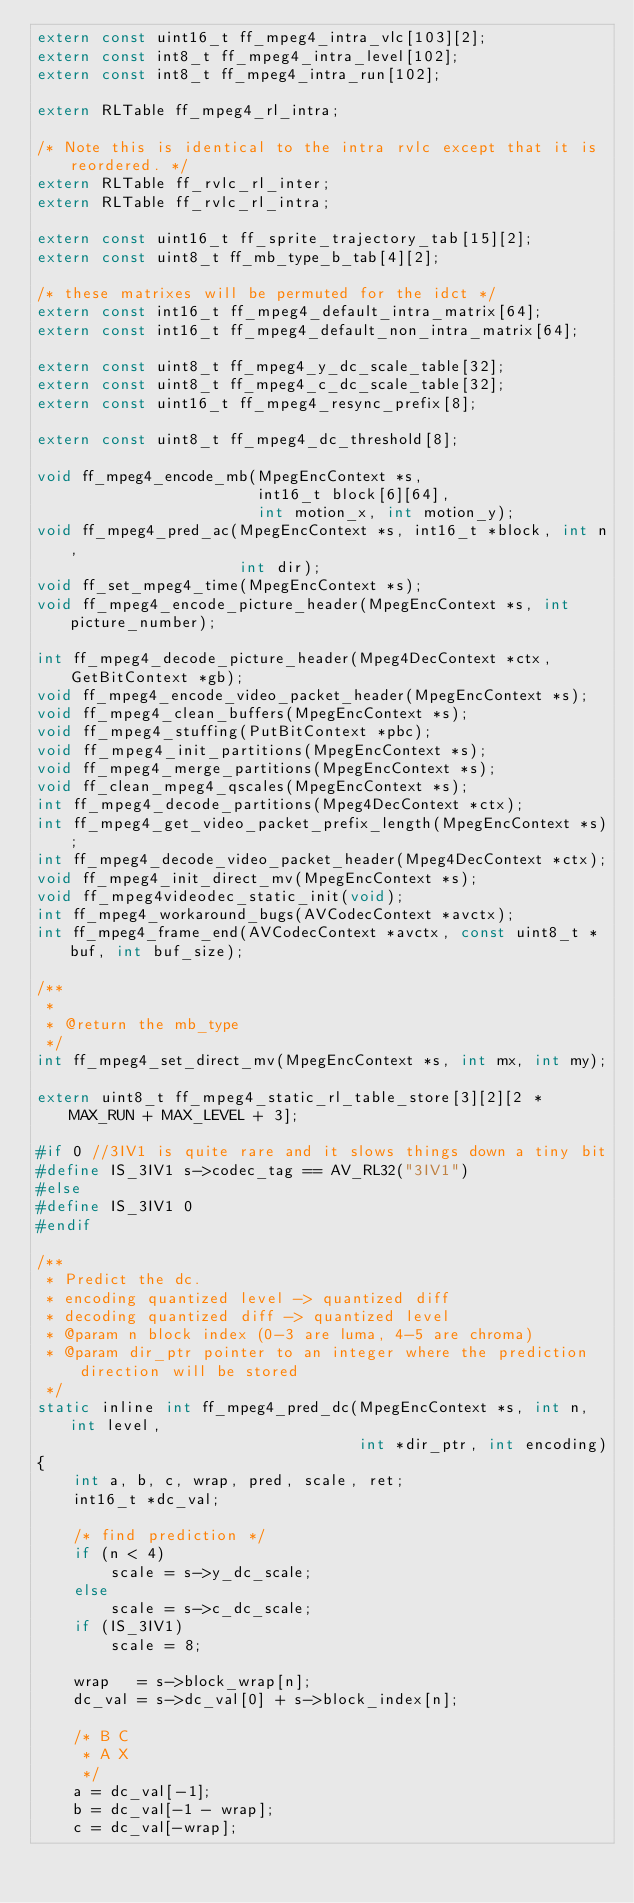Convert code to text. <code><loc_0><loc_0><loc_500><loc_500><_C_>extern const uint16_t ff_mpeg4_intra_vlc[103][2];
extern const int8_t ff_mpeg4_intra_level[102];
extern const int8_t ff_mpeg4_intra_run[102];

extern RLTable ff_mpeg4_rl_intra;

/* Note this is identical to the intra rvlc except that it is reordered. */
extern RLTable ff_rvlc_rl_inter;
extern RLTable ff_rvlc_rl_intra;

extern const uint16_t ff_sprite_trajectory_tab[15][2];
extern const uint8_t ff_mb_type_b_tab[4][2];

/* these matrixes will be permuted for the idct */
extern const int16_t ff_mpeg4_default_intra_matrix[64];
extern const int16_t ff_mpeg4_default_non_intra_matrix[64];

extern const uint8_t ff_mpeg4_y_dc_scale_table[32];
extern const uint8_t ff_mpeg4_c_dc_scale_table[32];
extern const uint16_t ff_mpeg4_resync_prefix[8];

extern const uint8_t ff_mpeg4_dc_threshold[8];

void ff_mpeg4_encode_mb(MpegEncContext *s,
                        int16_t block[6][64],
                        int motion_x, int motion_y);
void ff_mpeg4_pred_ac(MpegEncContext *s, int16_t *block, int n,
                      int dir);
void ff_set_mpeg4_time(MpegEncContext *s);
void ff_mpeg4_encode_picture_header(MpegEncContext *s, int picture_number);

int ff_mpeg4_decode_picture_header(Mpeg4DecContext *ctx, GetBitContext *gb);
void ff_mpeg4_encode_video_packet_header(MpegEncContext *s);
void ff_mpeg4_clean_buffers(MpegEncContext *s);
void ff_mpeg4_stuffing(PutBitContext *pbc);
void ff_mpeg4_init_partitions(MpegEncContext *s);
void ff_mpeg4_merge_partitions(MpegEncContext *s);
void ff_clean_mpeg4_qscales(MpegEncContext *s);
int ff_mpeg4_decode_partitions(Mpeg4DecContext *ctx);
int ff_mpeg4_get_video_packet_prefix_length(MpegEncContext *s);
int ff_mpeg4_decode_video_packet_header(Mpeg4DecContext *ctx);
void ff_mpeg4_init_direct_mv(MpegEncContext *s);
void ff_mpeg4videodec_static_init(void);
int ff_mpeg4_workaround_bugs(AVCodecContext *avctx);
int ff_mpeg4_frame_end(AVCodecContext *avctx, const uint8_t *buf, int buf_size);

/**
 *
 * @return the mb_type
 */
int ff_mpeg4_set_direct_mv(MpegEncContext *s, int mx, int my);

extern uint8_t ff_mpeg4_static_rl_table_store[3][2][2 * MAX_RUN + MAX_LEVEL + 3];

#if 0 //3IV1 is quite rare and it slows things down a tiny bit
#define IS_3IV1 s->codec_tag == AV_RL32("3IV1")
#else
#define IS_3IV1 0
#endif

/**
 * Predict the dc.
 * encoding quantized level -> quantized diff
 * decoding quantized diff -> quantized level
 * @param n block index (0-3 are luma, 4-5 are chroma)
 * @param dir_ptr pointer to an integer where the prediction direction will be stored
 */
static inline int ff_mpeg4_pred_dc(MpegEncContext *s, int n, int level,
                                   int *dir_ptr, int encoding)
{
    int a, b, c, wrap, pred, scale, ret;
    int16_t *dc_val;

    /* find prediction */
    if (n < 4)
        scale = s->y_dc_scale;
    else
        scale = s->c_dc_scale;
    if (IS_3IV1)
        scale = 8;

    wrap   = s->block_wrap[n];
    dc_val = s->dc_val[0] + s->block_index[n];

    /* B C
     * A X
     */
    a = dc_val[-1];
    b = dc_val[-1 - wrap];
    c = dc_val[-wrap];
</code> 